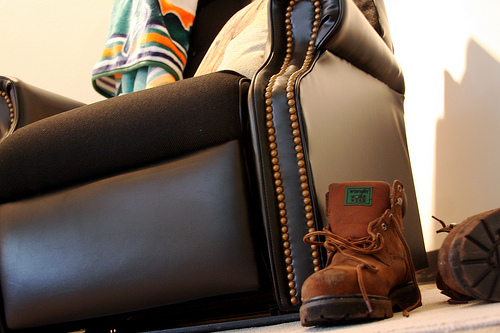<image>
Is the boot next to the chair? Yes. The boot is positioned adjacent to the chair, located nearby in the same general area. Where is the towel in relation to the chair? Is it on the chair? Yes. Looking at the image, I can see the towel is positioned on top of the chair, with the chair providing support. 